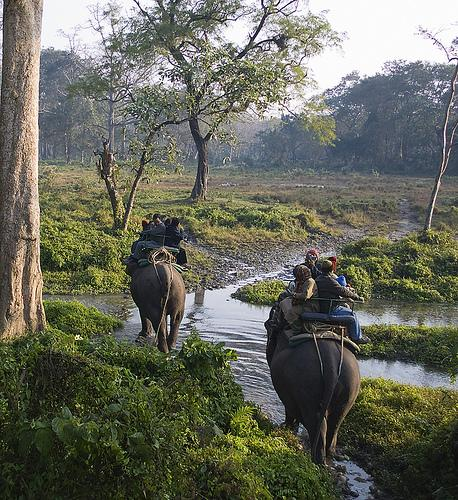Question: what are the people riding?
Choices:
A. Camels.
B. Horses.
C. Cattle.
D. Elephants.
Answer with the letter. Answer: D Question: how many elephants are there?
Choices:
A. Three.
B. Two.
C. Four.
D. Five.
Answer with the letter. Answer: B Question: what is in the distance?
Choices:
A. Trees.
B. Houses.
C. River.
D. Desert.
Answer with the letter. Answer: A Question: why are they riding the elephants?
Choices:
A. Avoid water.
B. For fun.
C. To go to town.
D. Cheap transportation.
Answer with the letter. Answer: A Question: who is on the elephants?
Choices:
A. Women.
B. Men.
C. Children.
D. Family.
Answer with the letter. Answer: B Question: what are the elephants walking through?
Choices:
A. Mud.
B. Forest.
C. Water.
D. High grass.
Answer with the letter. Answer: C 